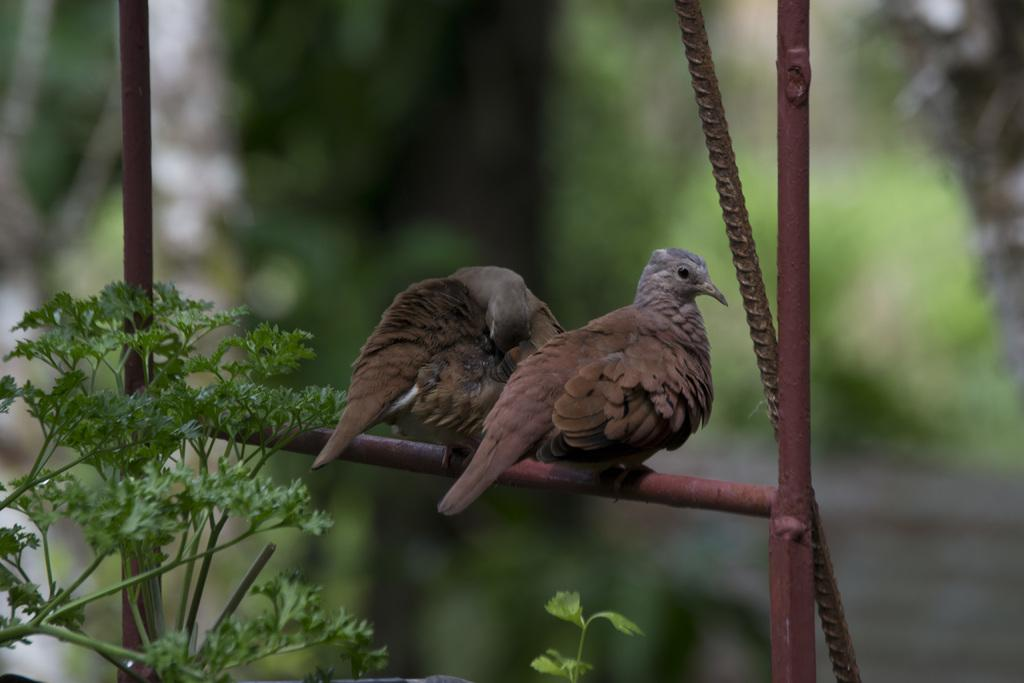What can be seen on the iron rod in the image? There are two birds on an iron rod in the image. What is located on the left side of the image? There are trees on the left side of the image. What color is the background of the image? The background of the image is green in color. How is the image blurred? The image is blurred in the background. How many rabbits can be seen in the image? There are no rabbits present in the image; it features two birds on an iron rod. What type of picture is being displayed in the image? There is no picture present in the image; it is a photograph of birds on an iron rod, trees, and a green background. 